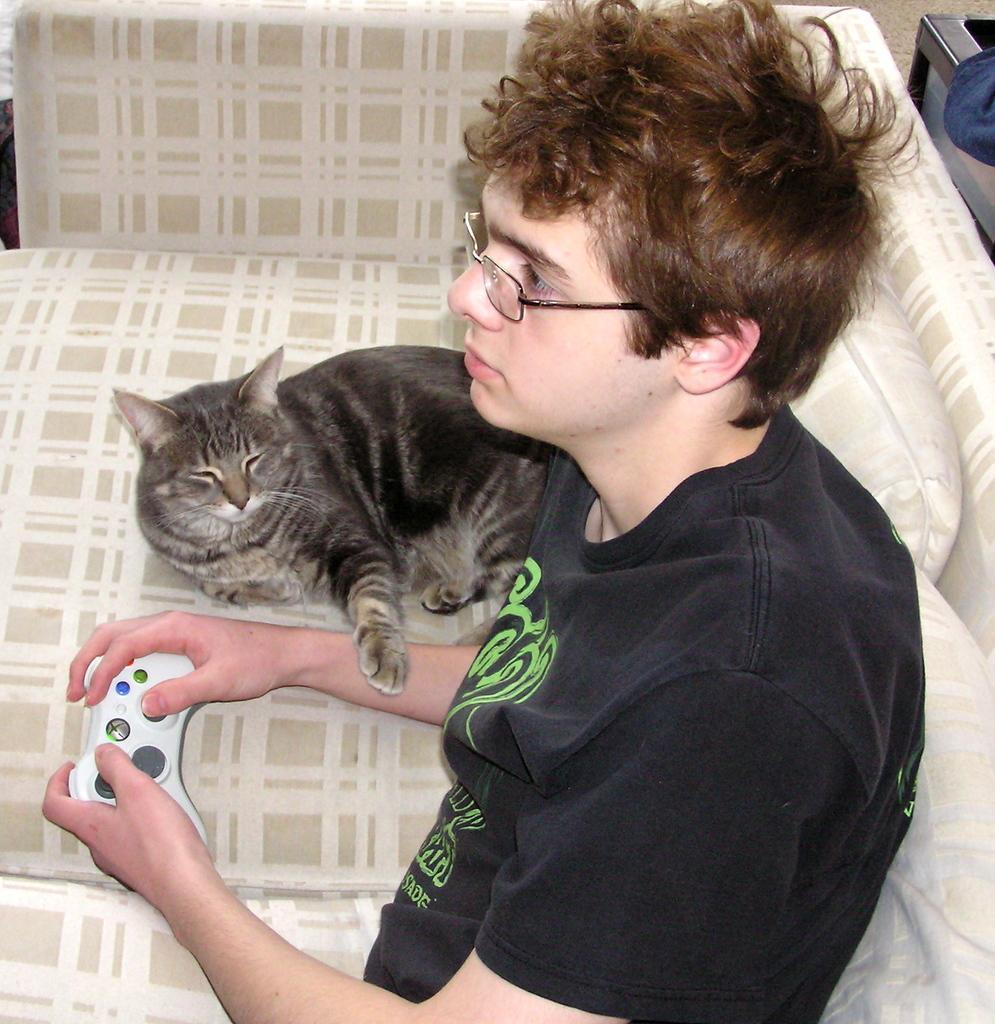How would you summarize this image in a sentence or two? In this image i can see a person sitting on a couch and holding a toy in his hand, i can also see a cat beside him lying on the couch. 